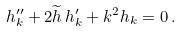<formula> <loc_0><loc_0><loc_500><loc_500>h _ { k } ^ { \prime \prime } + 2 \widetilde { h } \, h _ { k } ^ { \prime } + k ^ { 2 } h _ { k } = 0 \, .</formula> 